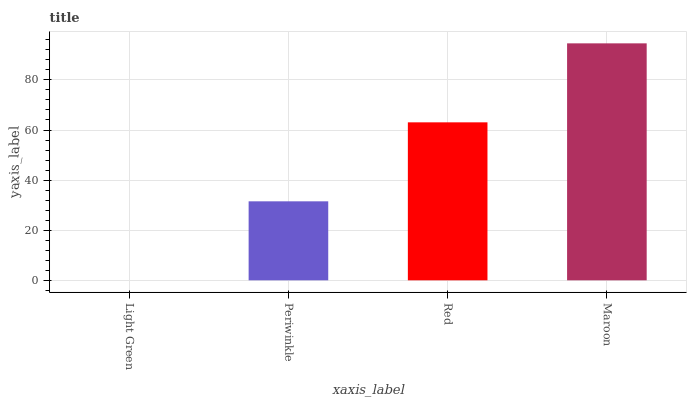Is Light Green the minimum?
Answer yes or no. Yes. Is Maroon the maximum?
Answer yes or no. Yes. Is Periwinkle the minimum?
Answer yes or no. No. Is Periwinkle the maximum?
Answer yes or no. No. Is Periwinkle greater than Light Green?
Answer yes or no. Yes. Is Light Green less than Periwinkle?
Answer yes or no. Yes. Is Light Green greater than Periwinkle?
Answer yes or no. No. Is Periwinkle less than Light Green?
Answer yes or no. No. Is Red the high median?
Answer yes or no. Yes. Is Periwinkle the low median?
Answer yes or no. Yes. Is Maroon the high median?
Answer yes or no. No. Is Maroon the low median?
Answer yes or no. No. 